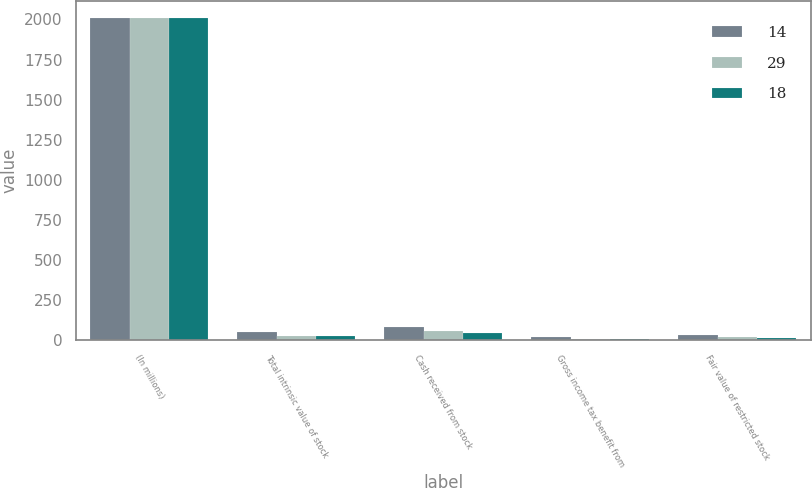Convert chart to OTSL. <chart><loc_0><loc_0><loc_500><loc_500><stacked_bar_chart><ecel><fcel>(In millions)<fcel>Total intrinsic value of stock<fcel>Cash received from stock<fcel>Gross income tax benefit from<fcel>Fair value of restricted stock<nl><fcel>14<fcel>2012<fcel>51<fcel>80<fcel>20<fcel>29<nl><fcel>29<fcel>2011<fcel>26<fcel>54<fcel>10<fcel>18<nl><fcel>18<fcel>2010<fcel>23<fcel>47<fcel>9<fcel>14<nl></chart> 